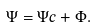<formula> <loc_0><loc_0><loc_500><loc_500>\Psi = \Psi c + \Phi .</formula> 